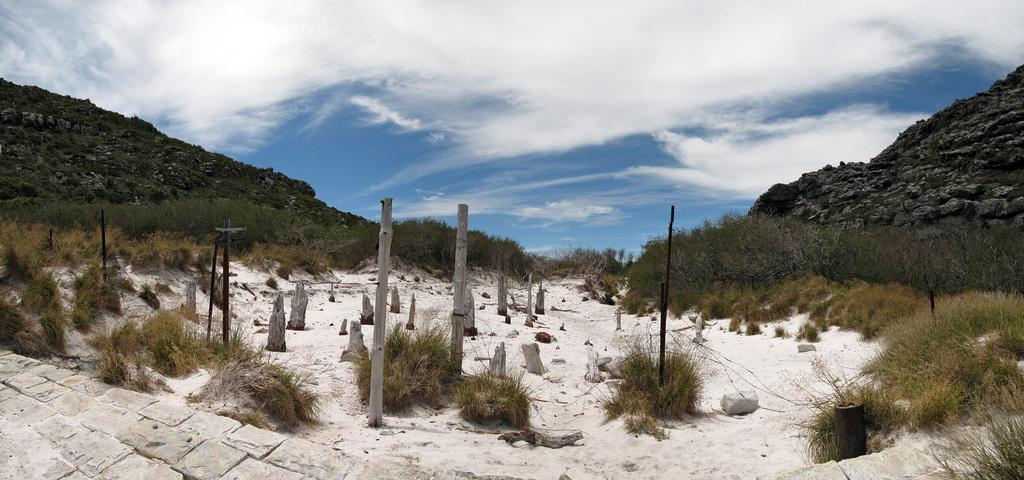What structures can be seen in the image? There are poles in the image. What type of vegetation is visible in the image? The grass is visible in the image, as well as plants and trees. What type of landscape feature is present in the image? Mountains are visible in the image. What part of the natural environment is visible in the background of the image? The sky is visible in the background of the image. What type of magic is being performed by the grandmother in the image? There is no grandmother or magic present in the image; it features poles, grass, plants, trees, mountains, and the sky. What type of machine is being used to maintain the plants in the image? There is no machine present in the image; the plants are being maintained naturally. 